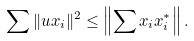<formula> <loc_0><loc_0><loc_500><loc_500>\sum \| u x _ { i } \| ^ { 2 } \leq \left \| \sum x _ { i } x ^ { * } _ { i } \right \| .</formula> 